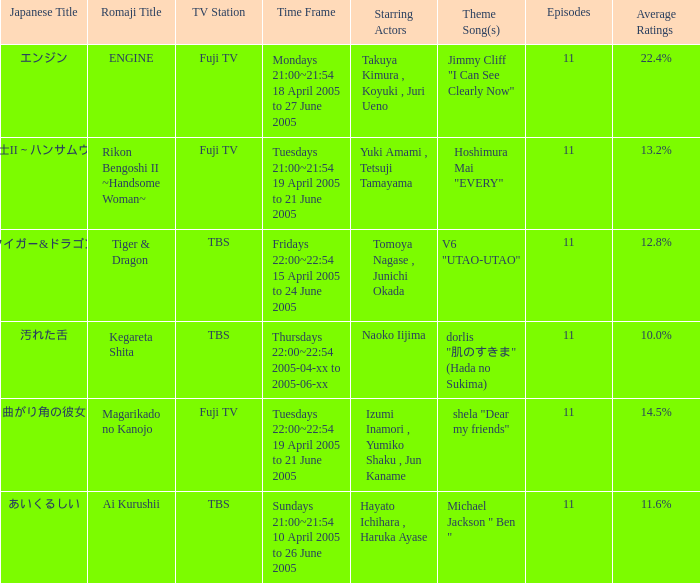What is maximum number of episodes for a show? 11.0. 